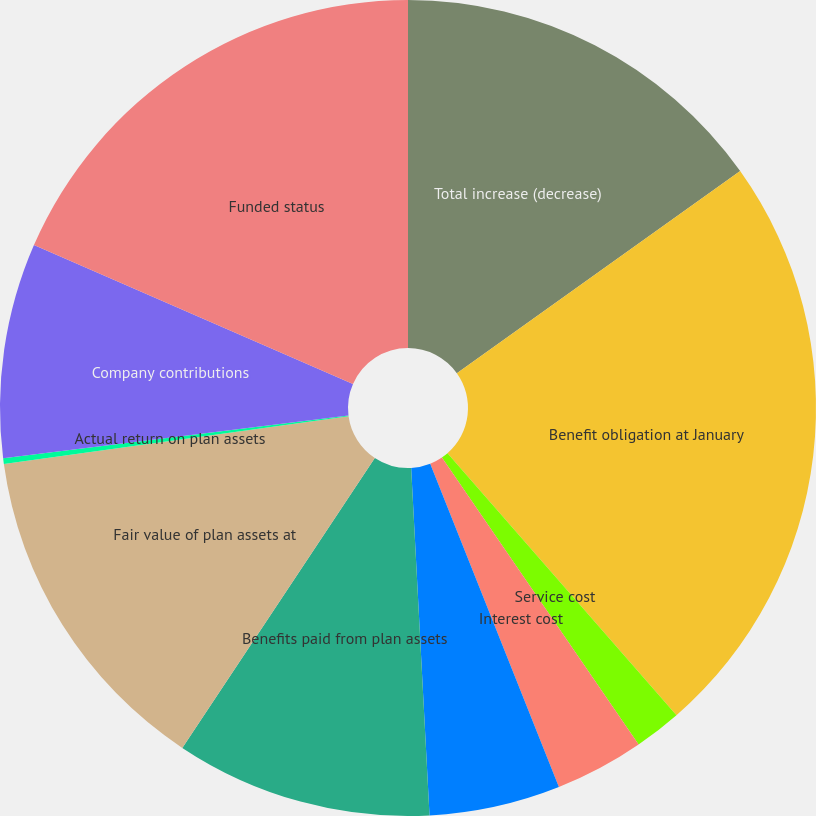<chart> <loc_0><loc_0><loc_500><loc_500><pie_chart><fcel>Total increase (decrease)<fcel>Benefit obligation at January<fcel>Service cost<fcel>Interest cost<fcel>Actuarial (gain) loss<fcel>Benefits paid from plan assets<fcel>Fair value of plan assets at<fcel>Actual return on plan assets<fcel>Company contributions<fcel>Funded status<nl><fcel>15.14%<fcel>23.43%<fcel>1.87%<fcel>3.53%<fcel>5.19%<fcel>10.17%<fcel>13.48%<fcel>0.22%<fcel>8.51%<fcel>18.46%<nl></chart> 